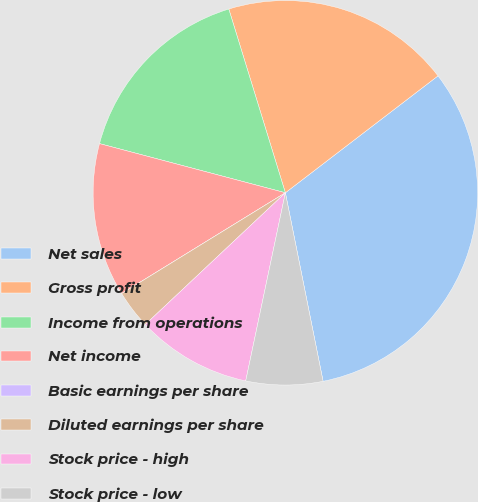Convert chart. <chart><loc_0><loc_0><loc_500><loc_500><pie_chart><fcel>Net sales<fcel>Gross profit<fcel>Income from operations<fcel>Net income<fcel>Basic earnings per share<fcel>Diluted earnings per share<fcel>Stock price - high<fcel>Stock price - low<nl><fcel>32.26%<fcel>19.35%<fcel>16.13%<fcel>12.9%<fcel>0.0%<fcel>3.23%<fcel>9.68%<fcel>6.45%<nl></chart> 